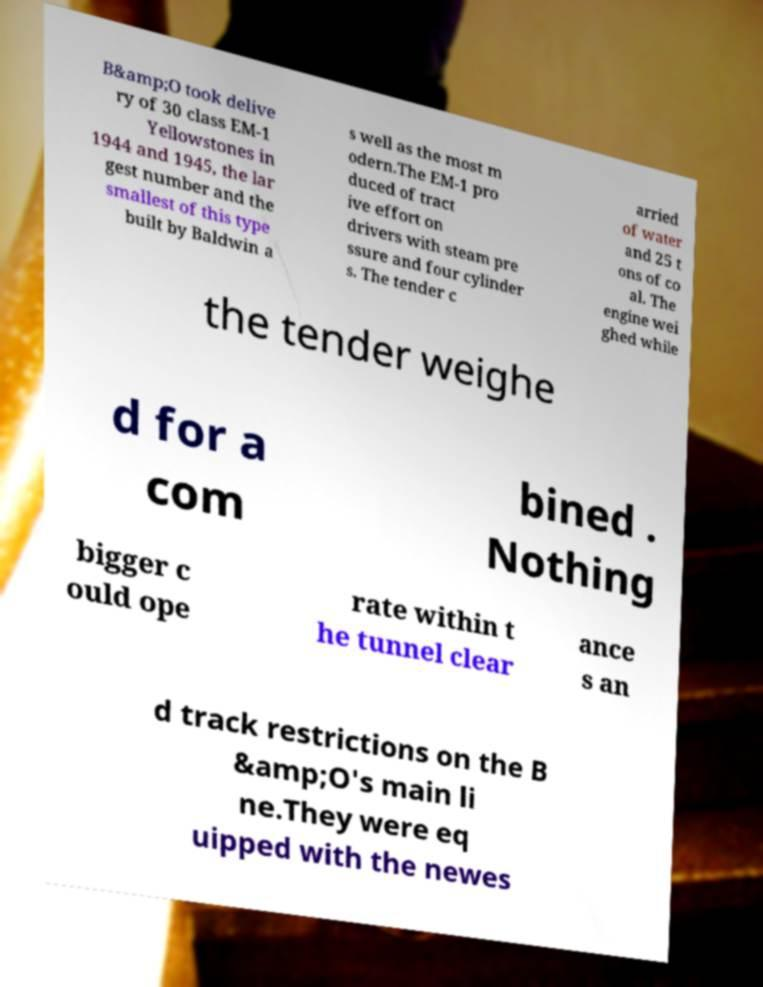There's text embedded in this image that I need extracted. Can you transcribe it verbatim? B&amp;O took delive ry of 30 class EM-1 Yellowstones in 1944 and 1945, the lar gest number and the smallest of this type built by Baldwin a s well as the most m odern.The EM-1 pro duced of tract ive effort on drivers with steam pre ssure and four cylinder s. The tender c arried of water and 25 t ons of co al. The engine wei ghed while the tender weighe d for a com bined . Nothing bigger c ould ope rate within t he tunnel clear ance s an d track restrictions on the B &amp;O's main li ne.They were eq uipped with the newes 